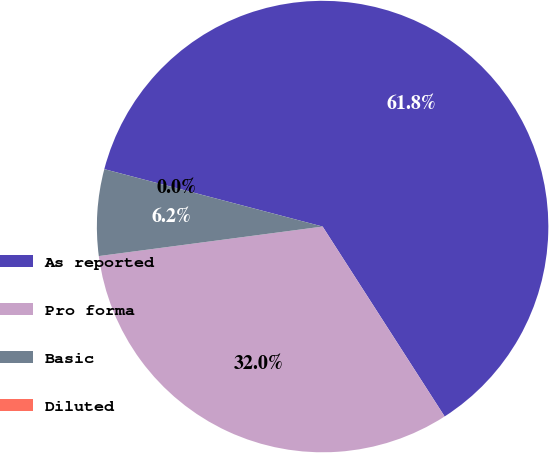<chart> <loc_0><loc_0><loc_500><loc_500><pie_chart><fcel>As reported<fcel>Pro forma<fcel>Basic<fcel>Diluted<nl><fcel>61.81%<fcel>32.0%<fcel>6.18%<fcel>0.0%<nl></chart> 